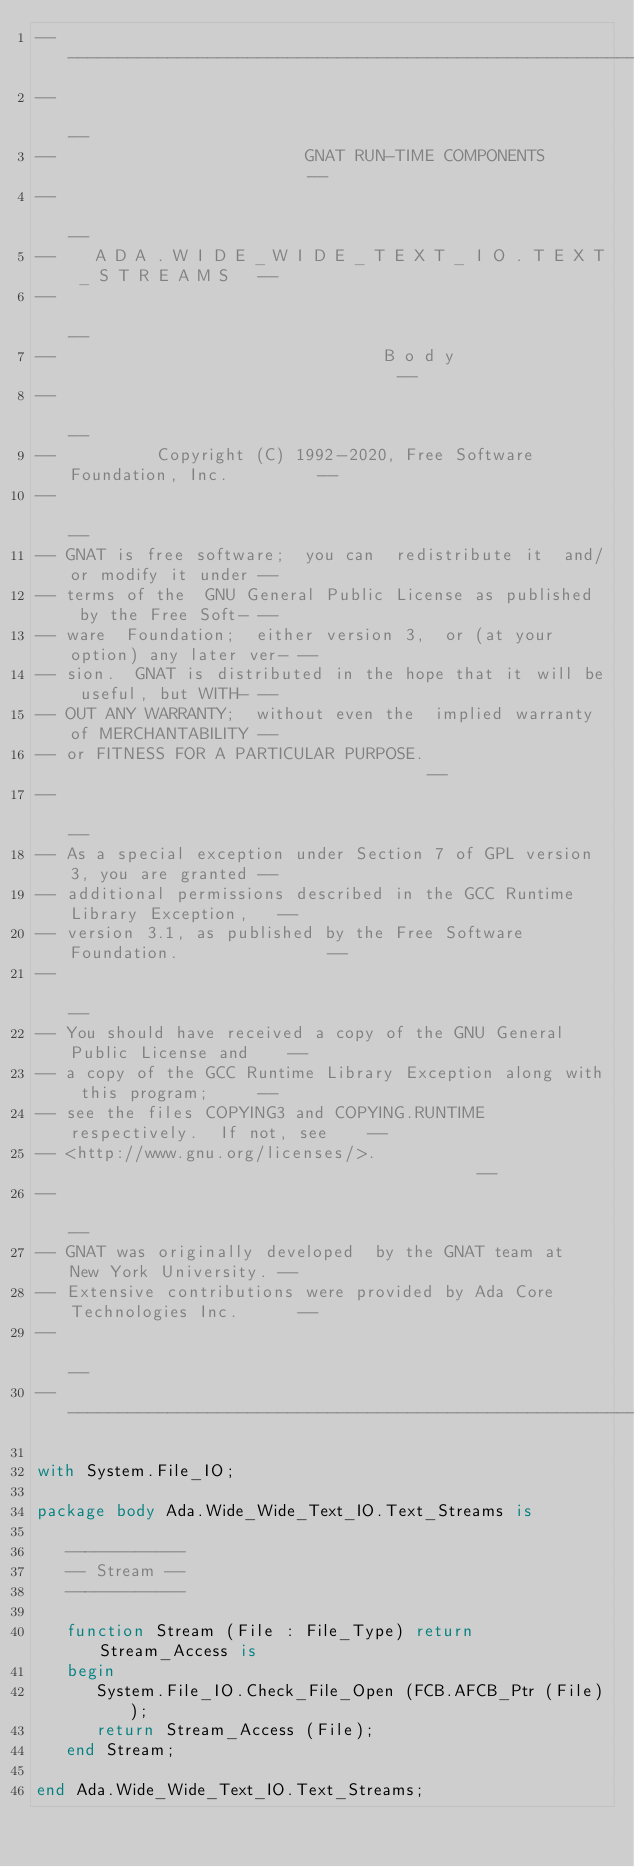Convert code to text. <code><loc_0><loc_0><loc_500><loc_500><_Ada_>------------------------------------------------------------------------------
--                                                                          --
--                         GNAT RUN-TIME COMPONENTS                         --
--                                                                          --
--    A D A . W I D E _ W I D E _ T E X T _ I O . T E X T _ S T R E A M S   --
--                                                                          --
--                                 B o d y                                  --
--                                                                          --
--          Copyright (C) 1992-2020, Free Software Foundation, Inc.         --
--                                                                          --
-- GNAT is free software;  you can  redistribute it  and/or modify it under --
-- terms of the  GNU General Public License as published  by the Free Soft- --
-- ware  Foundation;  either version 3,  or (at your option) any later ver- --
-- sion.  GNAT is distributed in the hope that it will be useful, but WITH- --
-- OUT ANY WARRANTY;  without even the  implied warranty of MERCHANTABILITY --
-- or FITNESS FOR A PARTICULAR PURPOSE.                                     --
--                                                                          --
-- As a special exception under Section 7 of GPL version 3, you are granted --
-- additional permissions described in the GCC Runtime Library Exception,   --
-- version 3.1, as published by the Free Software Foundation.               --
--                                                                          --
-- You should have received a copy of the GNU General Public License and    --
-- a copy of the GCC Runtime Library Exception along with this program;     --
-- see the files COPYING3 and COPYING.RUNTIME respectively.  If not, see    --
-- <http://www.gnu.org/licenses/>.                                          --
--                                                                          --
-- GNAT was originally developed  by the GNAT team at  New York University. --
-- Extensive contributions were provided by Ada Core Technologies Inc.      --
--                                                                          --
------------------------------------------------------------------------------

with System.File_IO;

package body Ada.Wide_Wide_Text_IO.Text_Streams is

   ------------
   -- Stream --
   ------------

   function Stream (File : File_Type) return Stream_Access is
   begin
      System.File_IO.Check_File_Open (FCB.AFCB_Ptr (File));
      return Stream_Access (File);
   end Stream;

end Ada.Wide_Wide_Text_IO.Text_Streams;
</code> 